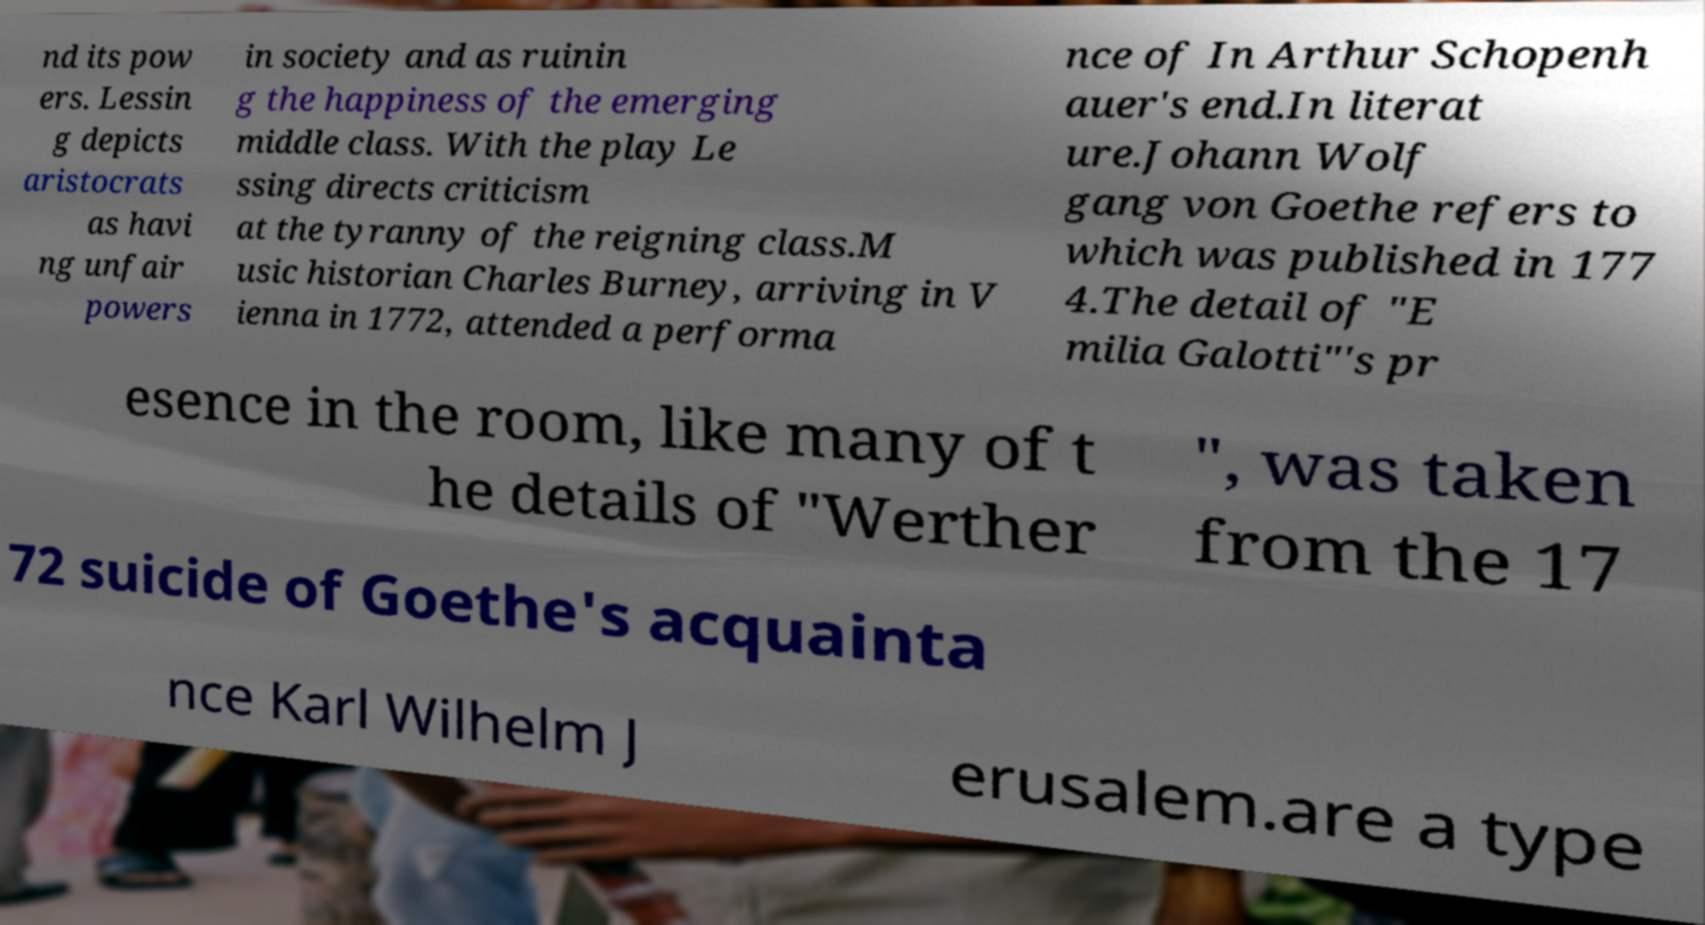Could you extract and type out the text from this image? nd its pow ers. Lessin g depicts aristocrats as havi ng unfair powers in society and as ruinin g the happiness of the emerging middle class. With the play Le ssing directs criticism at the tyranny of the reigning class.M usic historian Charles Burney, arriving in V ienna in 1772, attended a performa nce of In Arthur Schopenh auer's end.In literat ure.Johann Wolf gang von Goethe refers to which was published in 177 4.The detail of "E milia Galotti"'s pr esence in the room, like many of t he details of "Werther ", was taken from the 17 72 suicide of Goethe's acquainta nce Karl Wilhelm J erusalem.are a type 